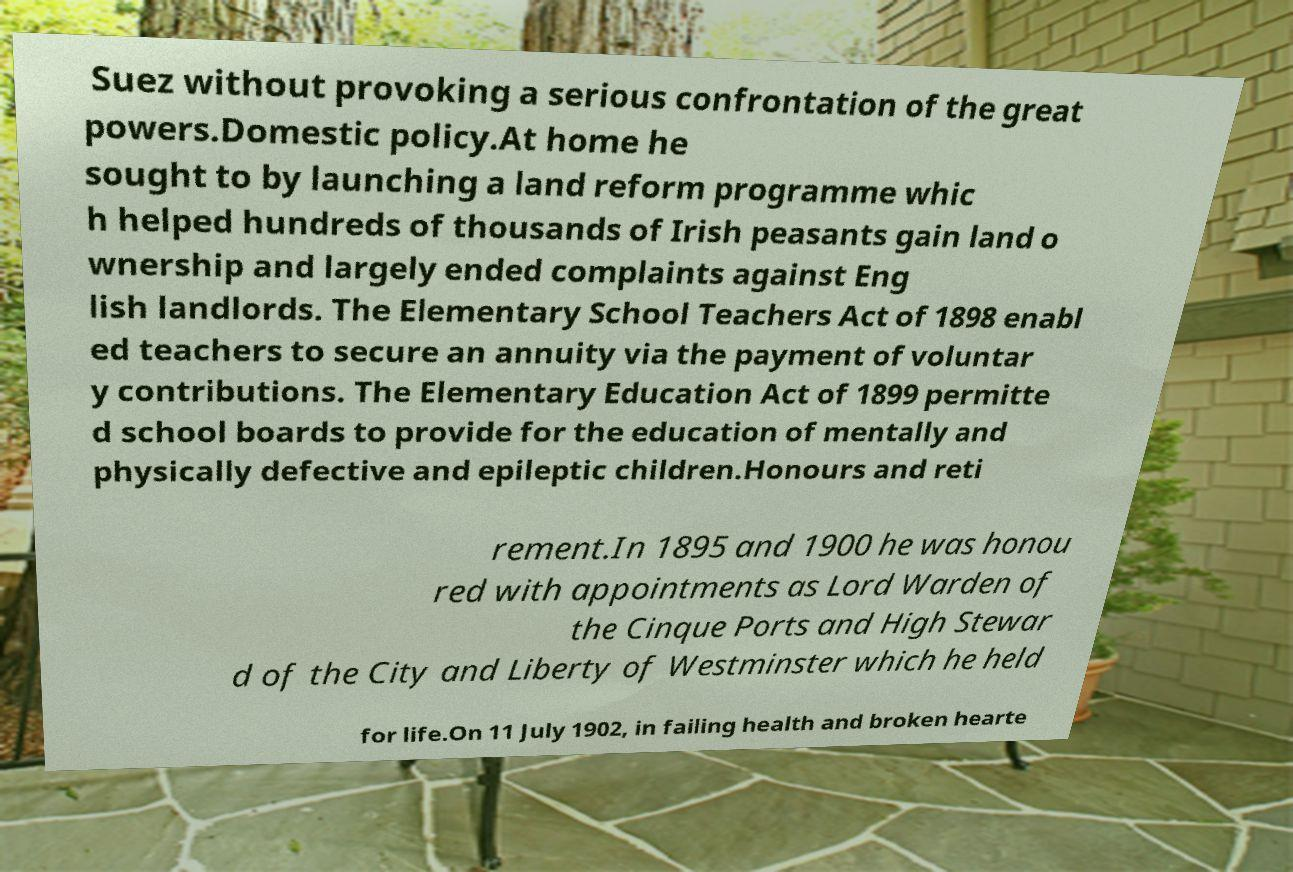What messages or text are displayed in this image? I need them in a readable, typed format. Suez without provoking a serious confrontation of the great powers.Domestic policy.At home he sought to by launching a land reform programme whic h helped hundreds of thousands of Irish peasants gain land o wnership and largely ended complaints against Eng lish landlords. The Elementary School Teachers Act of 1898 enabl ed teachers to secure an annuity via the payment of voluntar y contributions. The Elementary Education Act of 1899 permitte d school boards to provide for the education of mentally and physically defective and epileptic children.Honours and reti rement.In 1895 and 1900 he was honou red with appointments as Lord Warden of the Cinque Ports and High Stewar d of the City and Liberty of Westminster which he held for life.On 11 July 1902, in failing health and broken hearte 